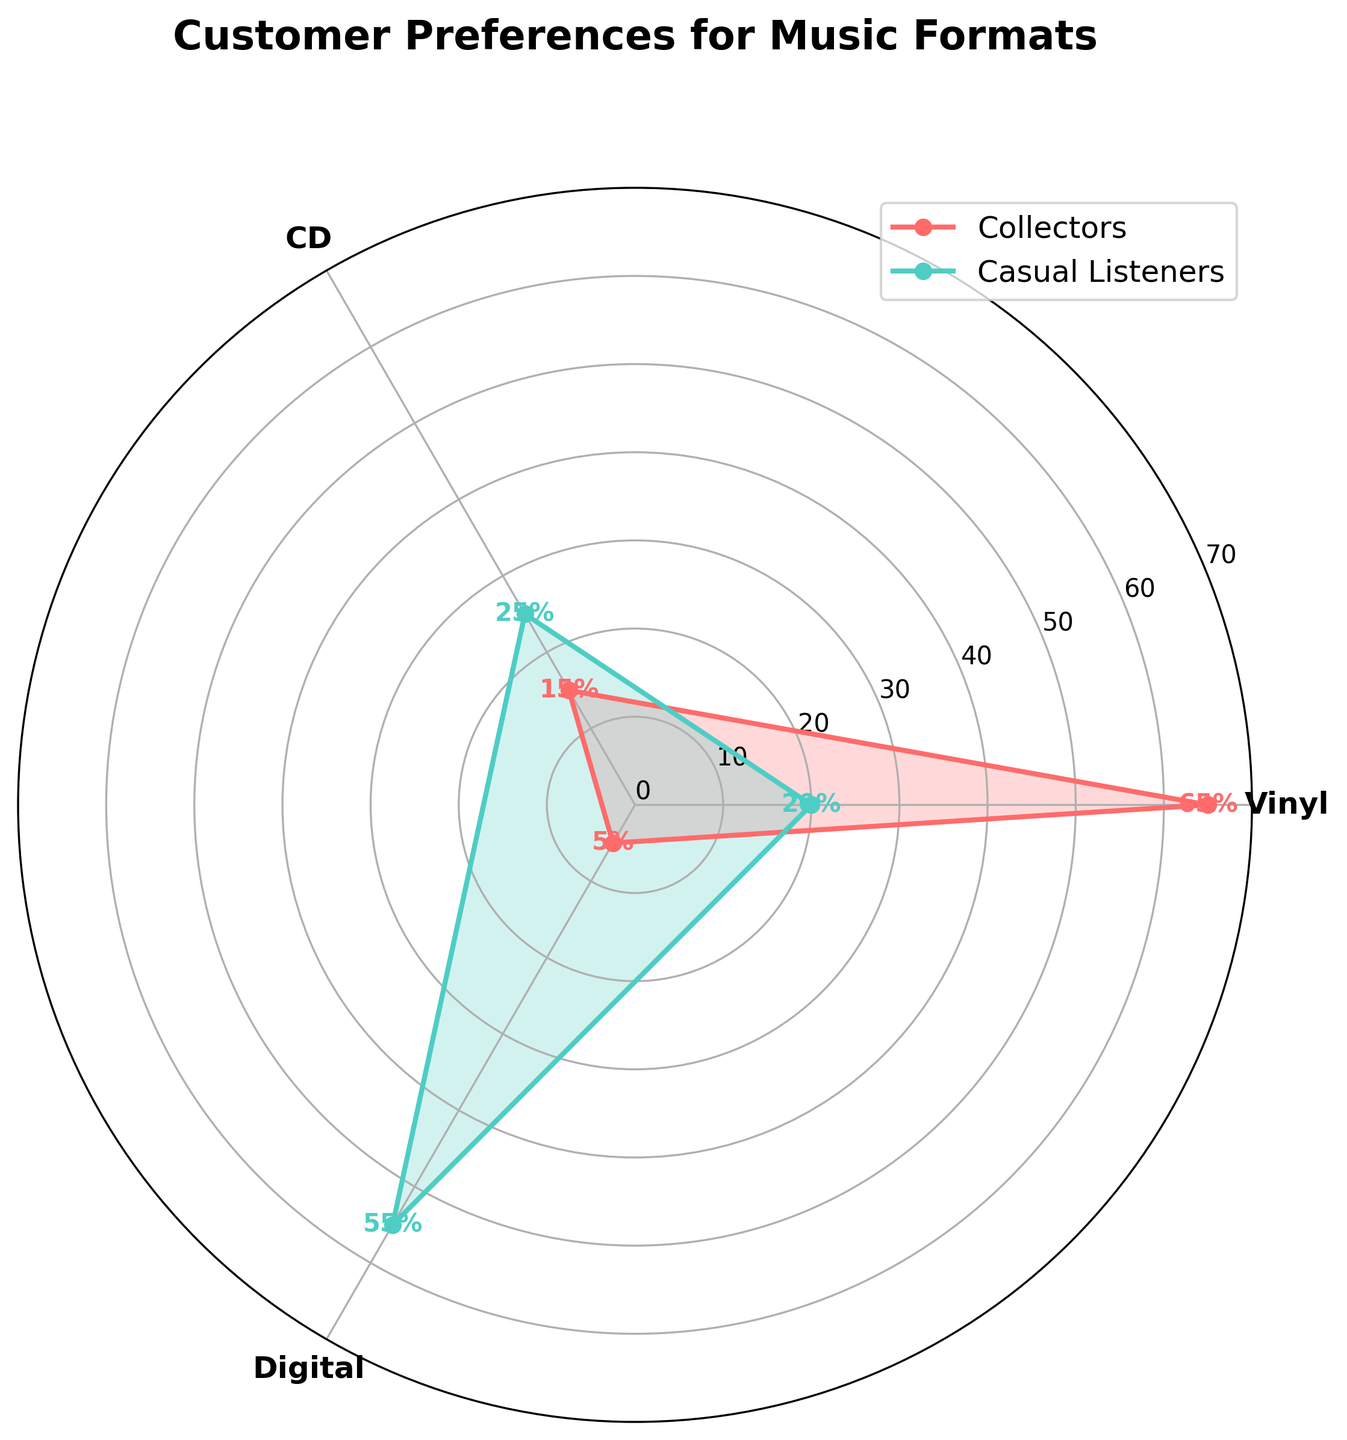Which format do Collectors prefer the most? Looking at the figure, the line representing Collectors for Vinyl is the longest and extends to 65%, which is the highest percentage among all formats for Collectors.
Answer: Vinyl Which Customer Group has the highest percentage for Digital format? The line representing Casual Listeners for Digital is the longest for that format and extends to 55%, which is higher than the 5% for Collectors.
Answer: Casual Listeners What is the combined preference percentage for CDs among all Customer Groups? CD preference is represented by 15% for Collectors and 25% for Casual Listeners. Adding these gives 15% + 25% = 40%.
Answer: 40% Which Customer Group has the least preference for CDs? Comparing the percentages for CDs, Collectors have a 15% preference and Casual Listeners have a 25% preference. 15% is smaller.
Answer: Collectors What is the average preference percentage for Casual Listeners across all formats? The percentages for Casual Listeners are 20% for Vinyl, 25% for CD, and 55% for Digital. Calculating the average: (20 + 25 + 55)/3 = 100/3 ≈ 33.33%.
Answer: 33.33% How does the preference for Vinyl compare between Collectors and Casual Listeners? Based on the figure, Collectors have a 65% preference for Vinyl, while Casual Listeners have a 20% preference. 65% is significantly greater than 20%.
Answer: Collectors prefer Vinyl more Which format has the lowest overall preference when combining both Customer Groups? Adding the percentages together: Vinyl (65 + 20 = 85), CD (15 + 25 = 40), Digital (5 + 55 = 60). The lowest combined percentage is for CDs at 40%.
Answer: CD Compare the preference percentage for Vinyl between the two Customer Groups and calculate the difference. Collectors have a 65% preference for Vinyl, while Casual Listeners have a 20% preference. The difference is 65% - 20% = 45%.
Answer: 45% 